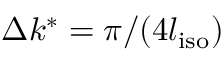Convert formula to latex. <formula><loc_0><loc_0><loc_500><loc_500>\Delta k ^ { * } = \pi / ( 4 l _ { i s o } )</formula> 